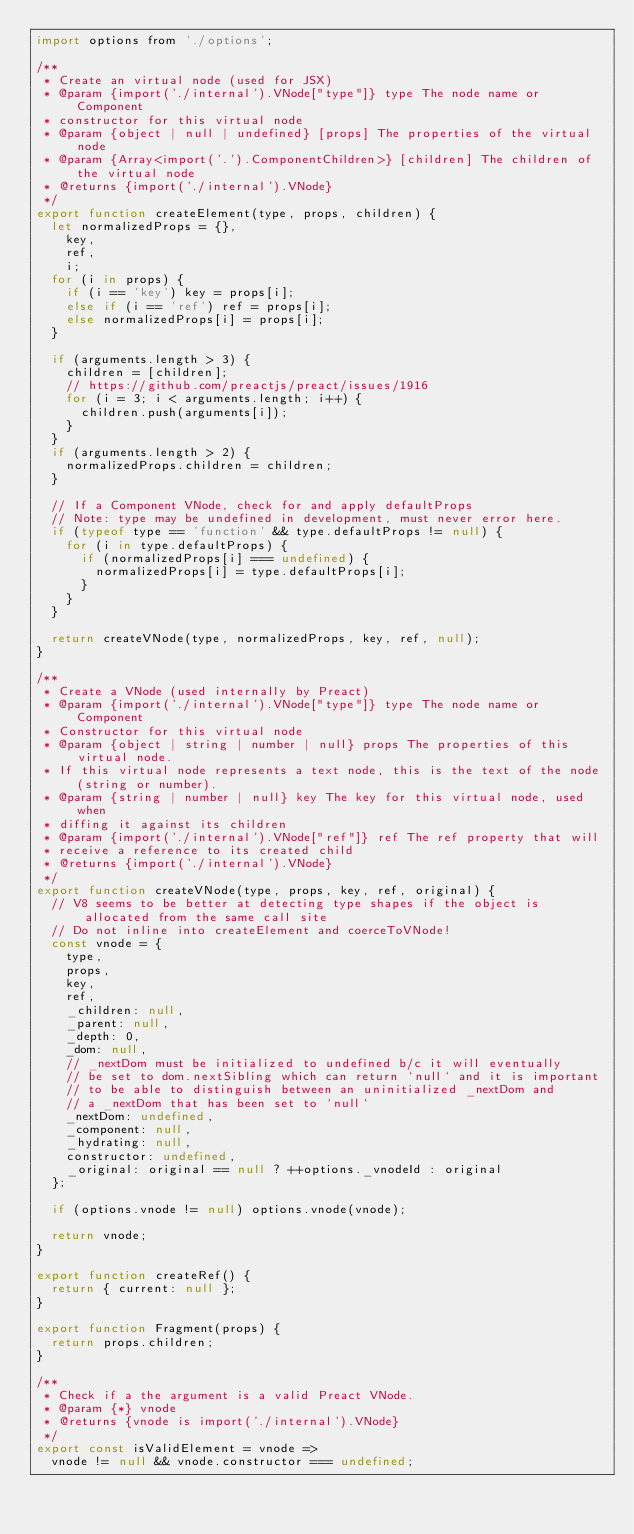<code> <loc_0><loc_0><loc_500><loc_500><_JavaScript_>import options from './options';

/**
 * Create an virtual node (used for JSX)
 * @param {import('./internal').VNode["type"]} type The node name or Component
 * constructor for this virtual node
 * @param {object | null | undefined} [props] The properties of the virtual node
 * @param {Array<import('.').ComponentChildren>} [children] The children of the virtual node
 * @returns {import('./internal').VNode}
 */
export function createElement(type, props, children) {
	let normalizedProps = {},
		key,
		ref,
		i;
	for (i in props) {
		if (i == 'key') key = props[i];
		else if (i == 'ref') ref = props[i];
		else normalizedProps[i] = props[i];
	}

	if (arguments.length > 3) {
		children = [children];
		// https://github.com/preactjs/preact/issues/1916
		for (i = 3; i < arguments.length; i++) {
			children.push(arguments[i]);
		}
	}
	if (arguments.length > 2) {
		normalizedProps.children = children;
	}

	// If a Component VNode, check for and apply defaultProps
	// Note: type may be undefined in development, must never error here.
	if (typeof type == 'function' && type.defaultProps != null) {
		for (i in type.defaultProps) {
			if (normalizedProps[i] === undefined) {
				normalizedProps[i] = type.defaultProps[i];
			}
		}
	}

	return createVNode(type, normalizedProps, key, ref, null);
}

/**
 * Create a VNode (used internally by Preact)
 * @param {import('./internal').VNode["type"]} type The node name or Component
 * Constructor for this virtual node
 * @param {object | string | number | null} props The properties of this virtual node.
 * If this virtual node represents a text node, this is the text of the node (string or number).
 * @param {string | number | null} key The key for this virtual node, used when
 * diffing it against its children
 * @param {import('./internal').VNode["ref"]} ref The ref property that will
 * receive a reference to its created child
 * @returns {import('./internal').VNode}
 */
export function createVNode(type, props, key, ref, original) {
	// V8 seems to be better at detecting type shapes if the object is allocated from the same call site
	// Do not inline into createElement and coerceToVNode!
	const vnode = {
		type,
		props,
		key,
		ref,
		_children: null,
		_parent: null,
		_depth: 0,
		_dom: null,
		// _nextDom must be initialized to undefined b/c it will eventually
		// be set to dom.nextSibling which can return `null` and it is important
		// to be able to distinguish between an uninitialized _nextDom and
		// a _nextDom that has been set to `null`
		_nextDom: undefined,
		_component: null,
		_hydrating: null,
		constructor: undefined,
		_original: original == null ? ++options._vnodeId : original
	};

	if (options.vnode != null) options.vnode(vnode);

	return vnode;
}

export function createRef() {
	return { current: null };
}

export function Fragment(props) {
	return props.children;
}

/**
 * Check if a the argument is a valid Preact VNode.
 * @param {*} vnode
 * @returns {vnode is import('./internal').VNode}
 */
export const isValidElement = vnode =>
	vnode != null && vnode.constructor === undefined;
</code> 